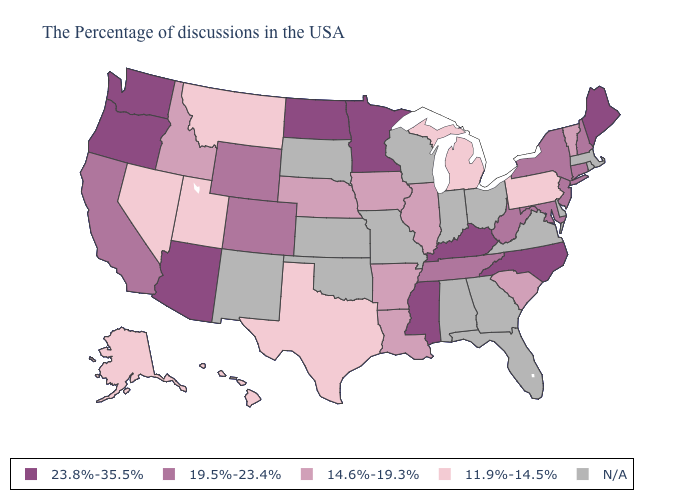Does Mississippi have the highest value in the South?
Keep it brief. Yes. Which states hav the highest value in the Northeast?
Quick response, please. Maine. Among the states that border Wyoming , which have the highest value?
Give a very brief answer. Colorado. Does the map have missing data?
Concise answer only. Yes. Among the states that border Kentucky , which have the highest value?
Write a very short answer. West Virginia, Tennessee. Which states have the lowest value in the MidWest?
Write a very short answer. Michigan. What is the value of New Jersey?
Answer briefly. 19.5%-23.4%. Does the first symbol in the legend represent the smallest category?
Be succinct. No. Does Louisiana have the lowest value in the South?
Concise answer only. No. What is the value of Missouri?
Be succinct. N/A. Does the first symbol in the legend represent the smallest category?
Quick response, please. No. Which states have the lowest value in the Northeast?
Quick response, please. Pennsylvania. What is the lowest value in the USA?
Short answer required. 11.9%-14.5%. Does Texas have the lowest value in the South?
Be succinct. Yes. 